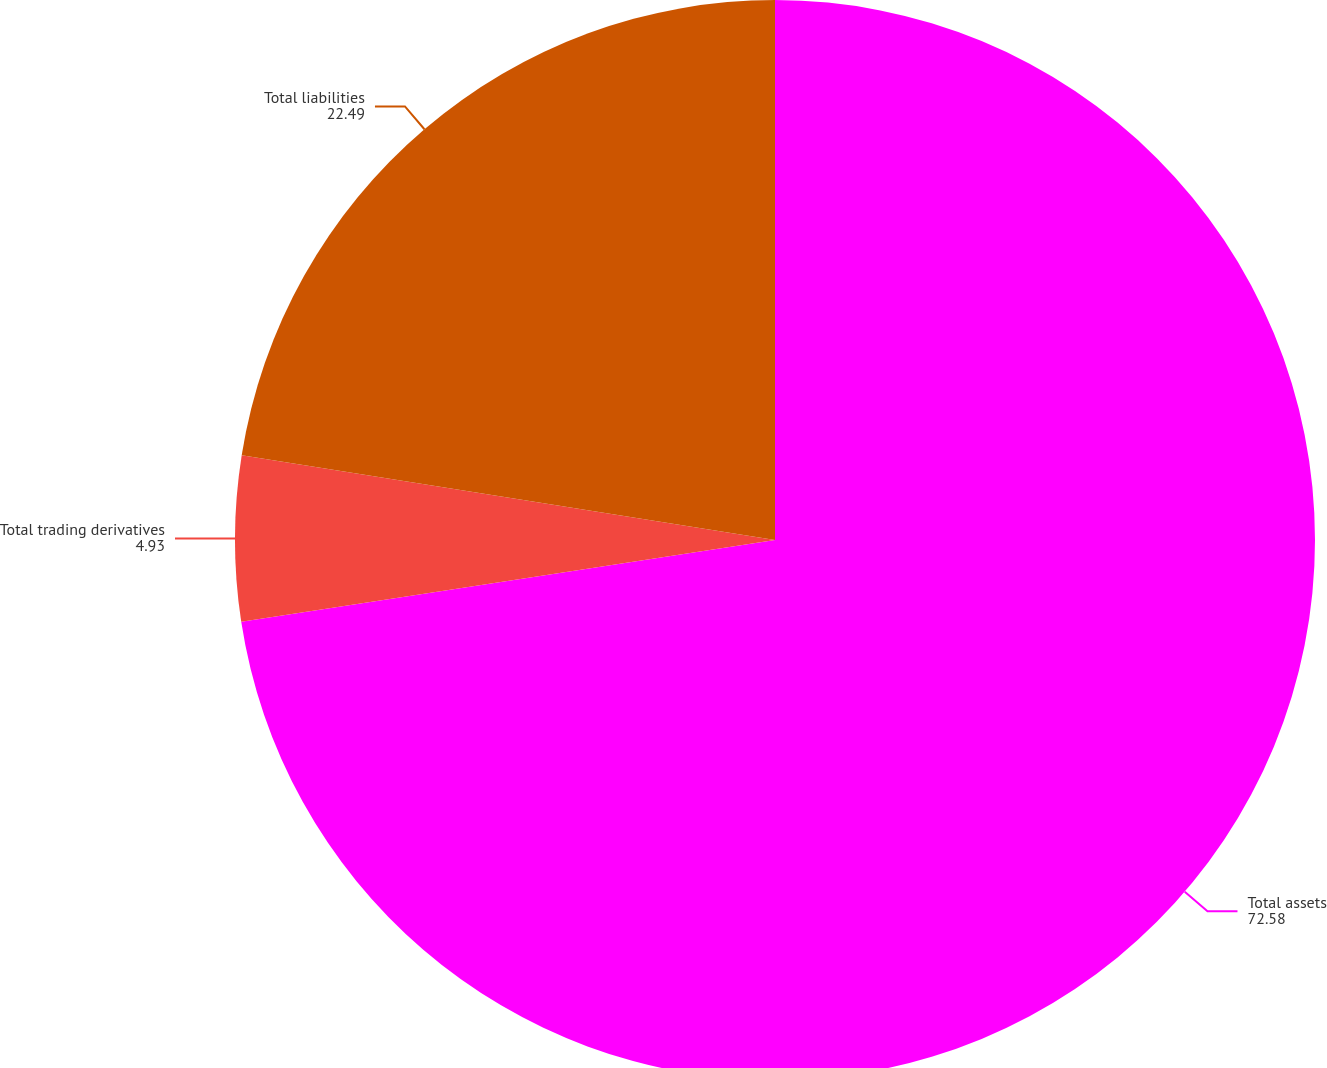Convert chart. <chart><loc_0><loc_0><loc_500><loc_500><pie_chart><fcel>Total assets<fcel>Total trading derivatives<fcel>Total liabilities<nl><fcel>72.58%<fcel>4.93%<fcel>22.49%<nl></chart> 